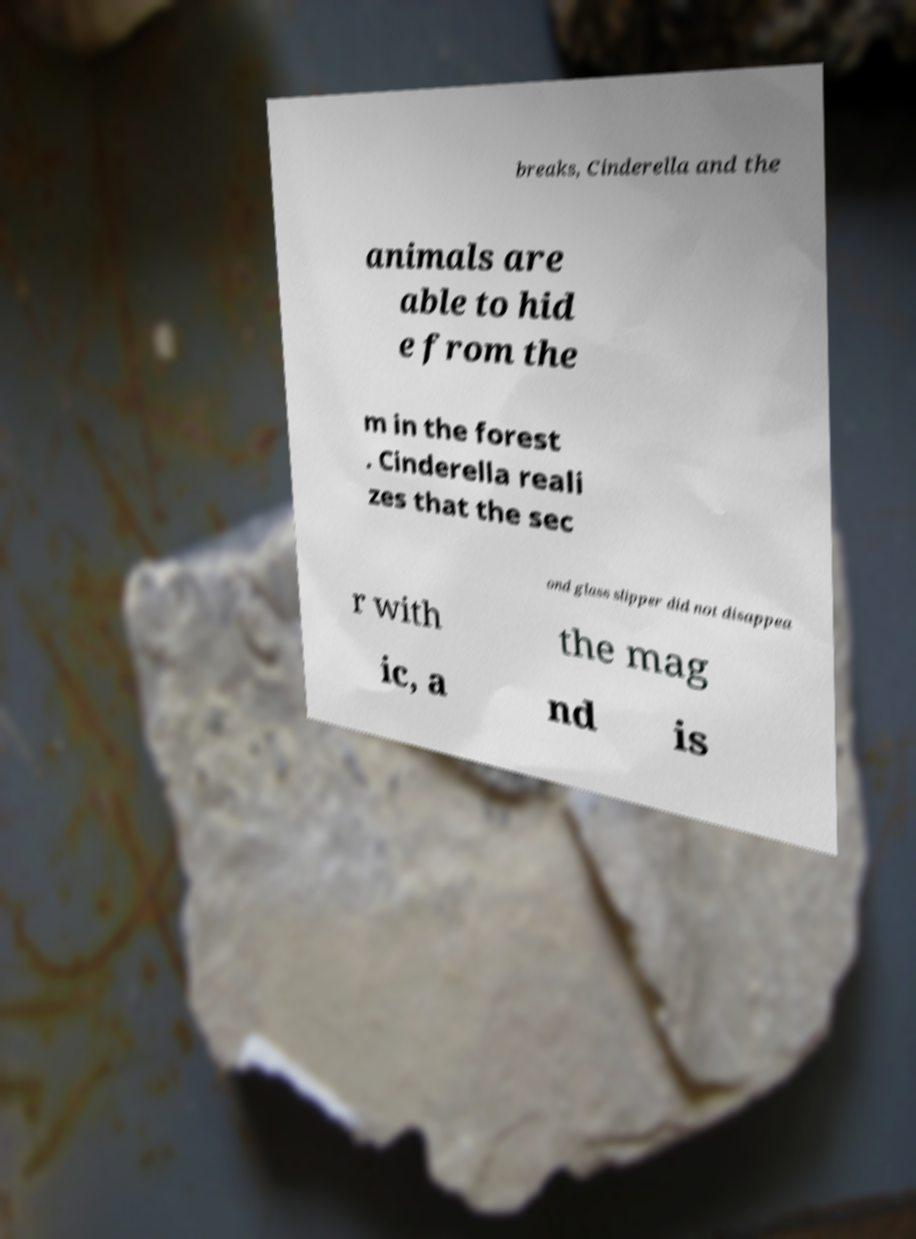Can you read and provide the text displayed in the image?This photo seems to have some interesting text. Can you extract and type it out for me? breaks, Cinderella and the animals are able to hid e from the m in the forest . Cinderella reali zes that the sec ond glass slipper did not disappea r with the mag ic, a nd is 